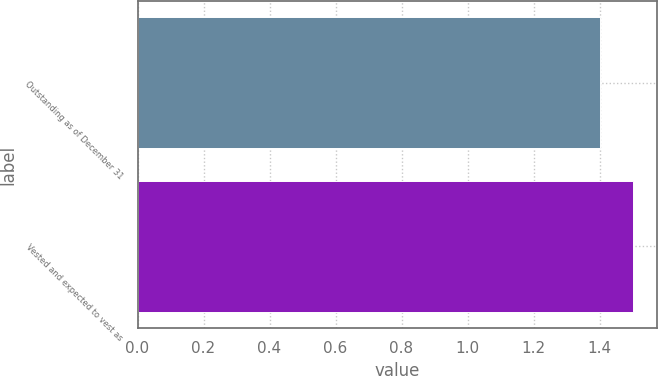Convert chart to OTSL. <chart><loc_0><loc_0><loc_500><loc_500><bar_chart><fcel>Outstanding as of December 31<fcel>Vested and expected to vest as<nl><fcel>1.4<fcel>1.5<nl></chart> 